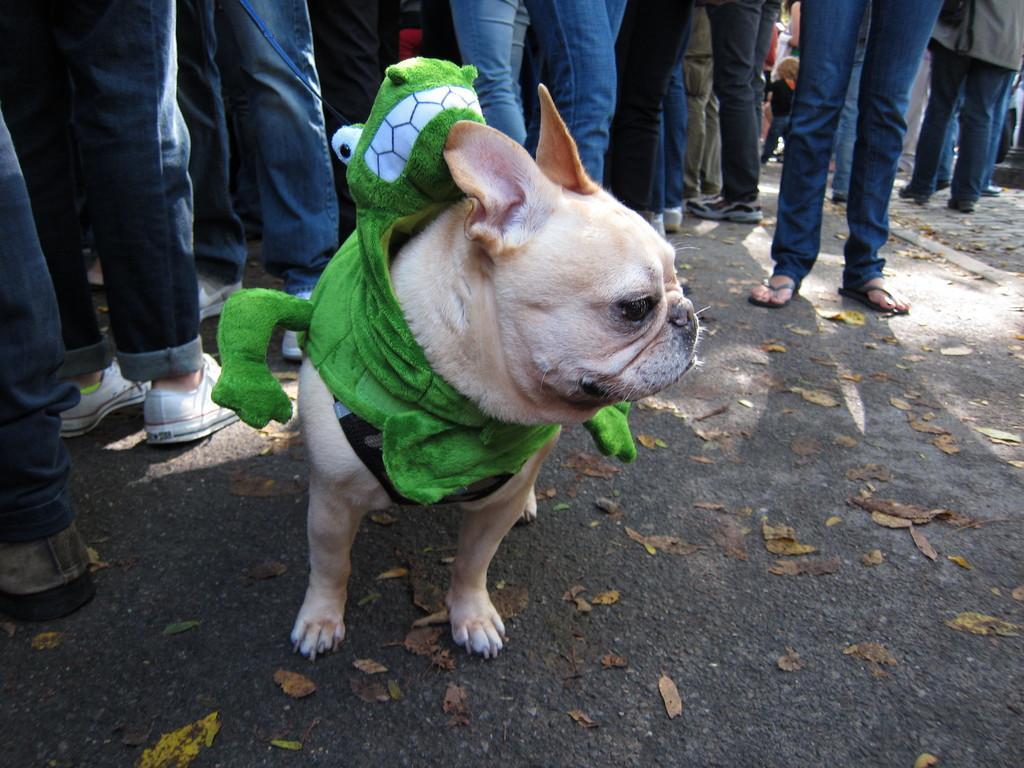Could you give a brief overview of what you see in this image? Here we can see a dog is standing on the road and there is a toy tied to the dog. In the background we can see few persons legs on the road. 